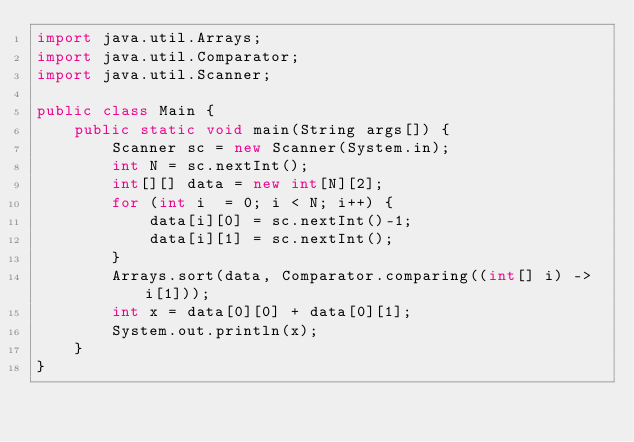<code> <loc_0><loc_0><loc_500><loc_500><_Java_>import java.util.Arrays;
import java.util.Comparator;
import java.util.Scanner;

public class Main {
    public static void main(String args[]) {
        Scanner sc = new Scanner(System.in);
        int N = sc.nextInt();
        int[][] data = new int[N][2];
        for (int i  = 0; i < N; i++) {
            data[i][0] = sc.nextInt()-1;
            data[i][1] = sc.nextInt();
        }
        Arrays.sort(data, Comparator.comparing((int[] i) -> i[1]));
        int x = data[0][0] + data[0][1];
        System.out.println(x);
    }
}</code> 